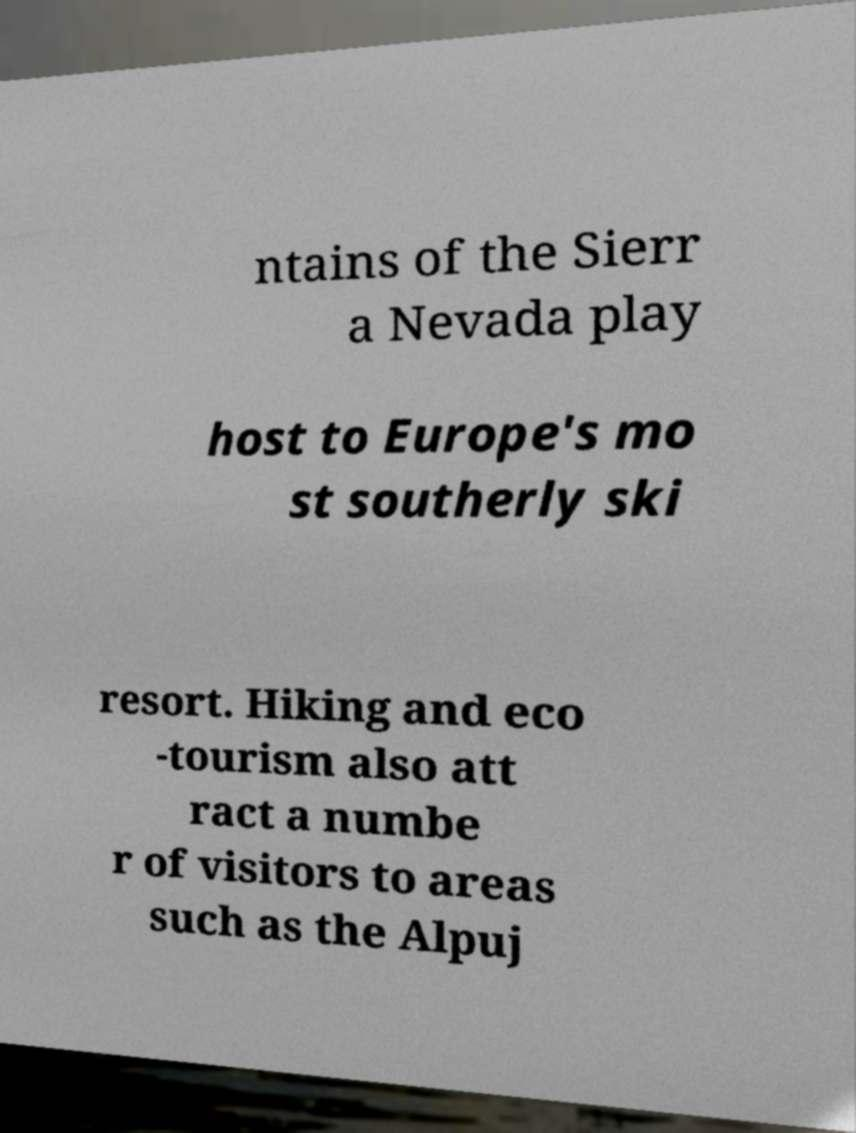Could you extract and type out the text from this image? ntains of the Sierr a Nevada play host to Europe's mo st southerly ski resort. Hiking and eco -tourism also att ract a numbe r of visitors to areas such as the Alpuj 